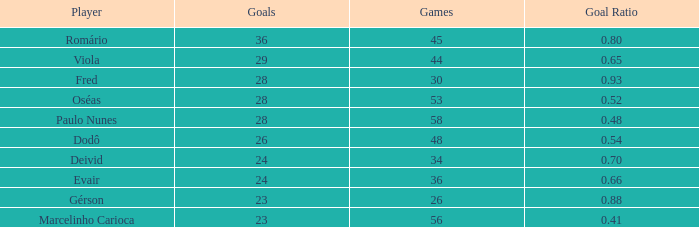How many goals have a goal ration less than 0.8 with 56 games? 1.0. 